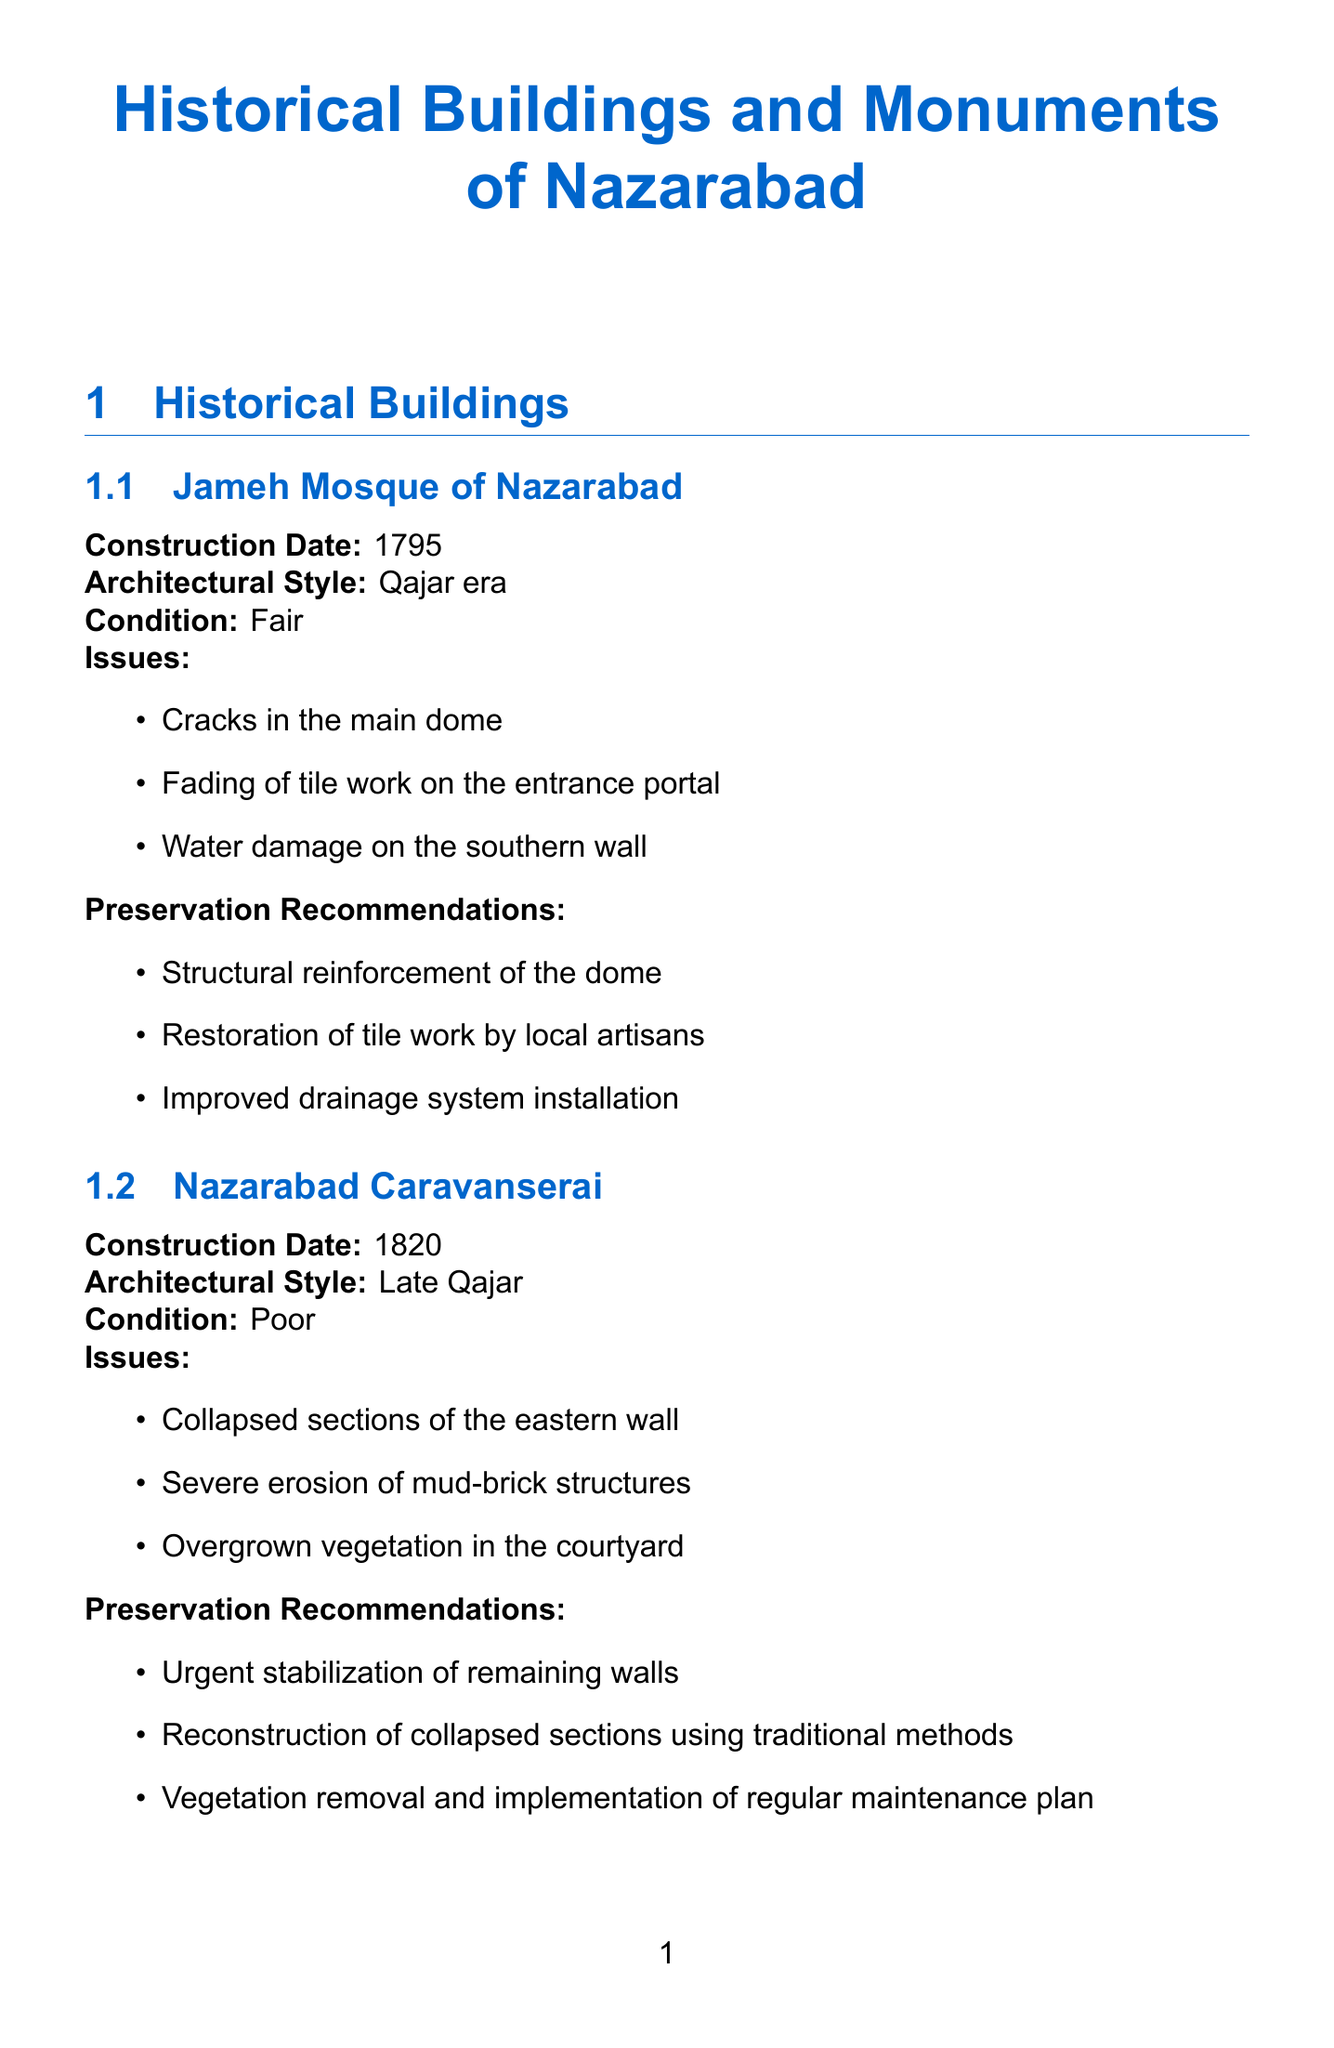what is the construction date of Jameh Mosque of Nazarabad? The construction date is provided as a specific date in the document.
Answer: 1795 what are the preservation recommendations for Nazarabad Caravanserai? The document lists specific recommendations to address issues found at the caravanserai.
Answer: Urgent stabilization of remaining walls, Reconstruction of collapsed sections using traditional methods, Vegetation removal and implementation of regular maintenance plan what is the current condition of Hosseiniyeh Azam? The document specifies the condition of the building in a straightforward manner.
Answer: Good what issues are reported for the Shahid Rajaee statue? The document enumerates issues related to the monument.
Answer: Oxidation of the bronze surface, Graffiti on the base which historical site is identified as being from the Bronze Age? The document categorizes historical sites by period, identifying specific ones.
Answer: Tappeh Ozbaki what is one significant preservation challenge listed in the document? The document explicitly mentions several challenges faced in preservation efforts.
Answer: Limited funding for conservation projects name a local resource involved in preservation efforts. The document identifies local organizations contributing to preservation efforts.
Answer: Nazarabad Cultural Heritage Office what is the installation date of the Nazarabad War Memorial? The installation date is clearly specified in the section about monuments.
Answer: 1990 